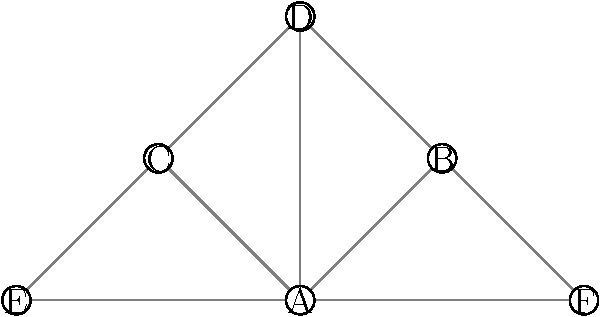You are organizing a fundraising dinner and need to optimize the seating arrangement based on the social network diagram provided. The diagram represents connections between key donors, where each node is a person and each edge represents a strong relationship. What is the minimum number of tables needed to seat all guests if you want to ensure that each table has at least one person who knows everyone else at that table? To solve this problem, we need to identify the maximum cliques in the social network graph. A clique is a subset of nodes where every node is connected to every other node in the subset.

Step 1: Identify all cliques in the graph.
- {A, B, D}
- {A, C, D}
- {A, B, F}
- {A, C, E}

Step 2: Determine the maximum cliques (largest cliques that are not subsets of other cliques).
The maximum cliques are:
- {A, B, D}
- {A, C, D}
- {A, B, F}
- {A, C, E}

Step 3: Count the number of maximum cliques.
There are 4 maximum cliques.

Step 4: Assign each maximum clique to a table.
- Table 1: {A, B, D}
- Table 2: {A, C, D}
- Table 3: {A, B, F}
- Table 4: {A, C, E}

This arrangement ensures that at each table, there is at least one person (A in this case) who knows everyone else at that table.

Therefore, the minimum number of tables needed is 4.
Answer: 4 tables 